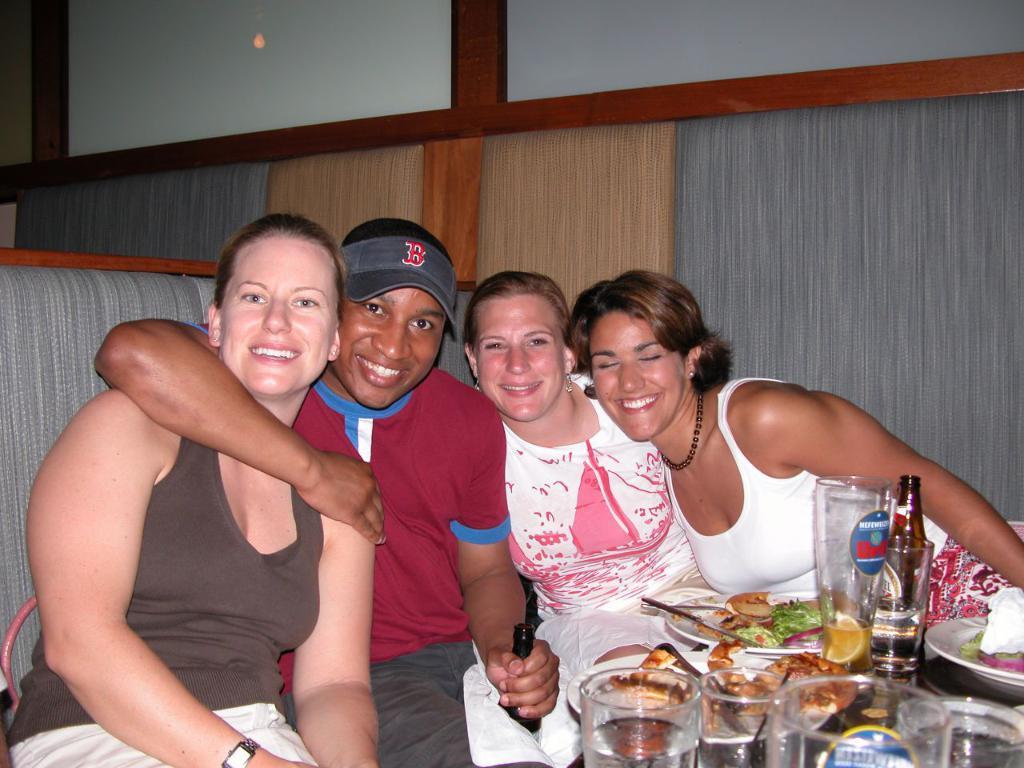Can you describe this image briefly? There are four persons posing to a camera and they are smiling. Here we can see glasses, bottles, plates, spoons, and food. 